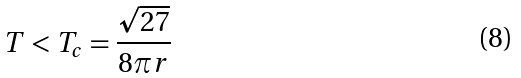<formula> <loc_0><loc_0><loc_500><loc_500>T < T _ { c } = \frac { \sqrt { 2 7 } } { 8 \pi r }</formula> 